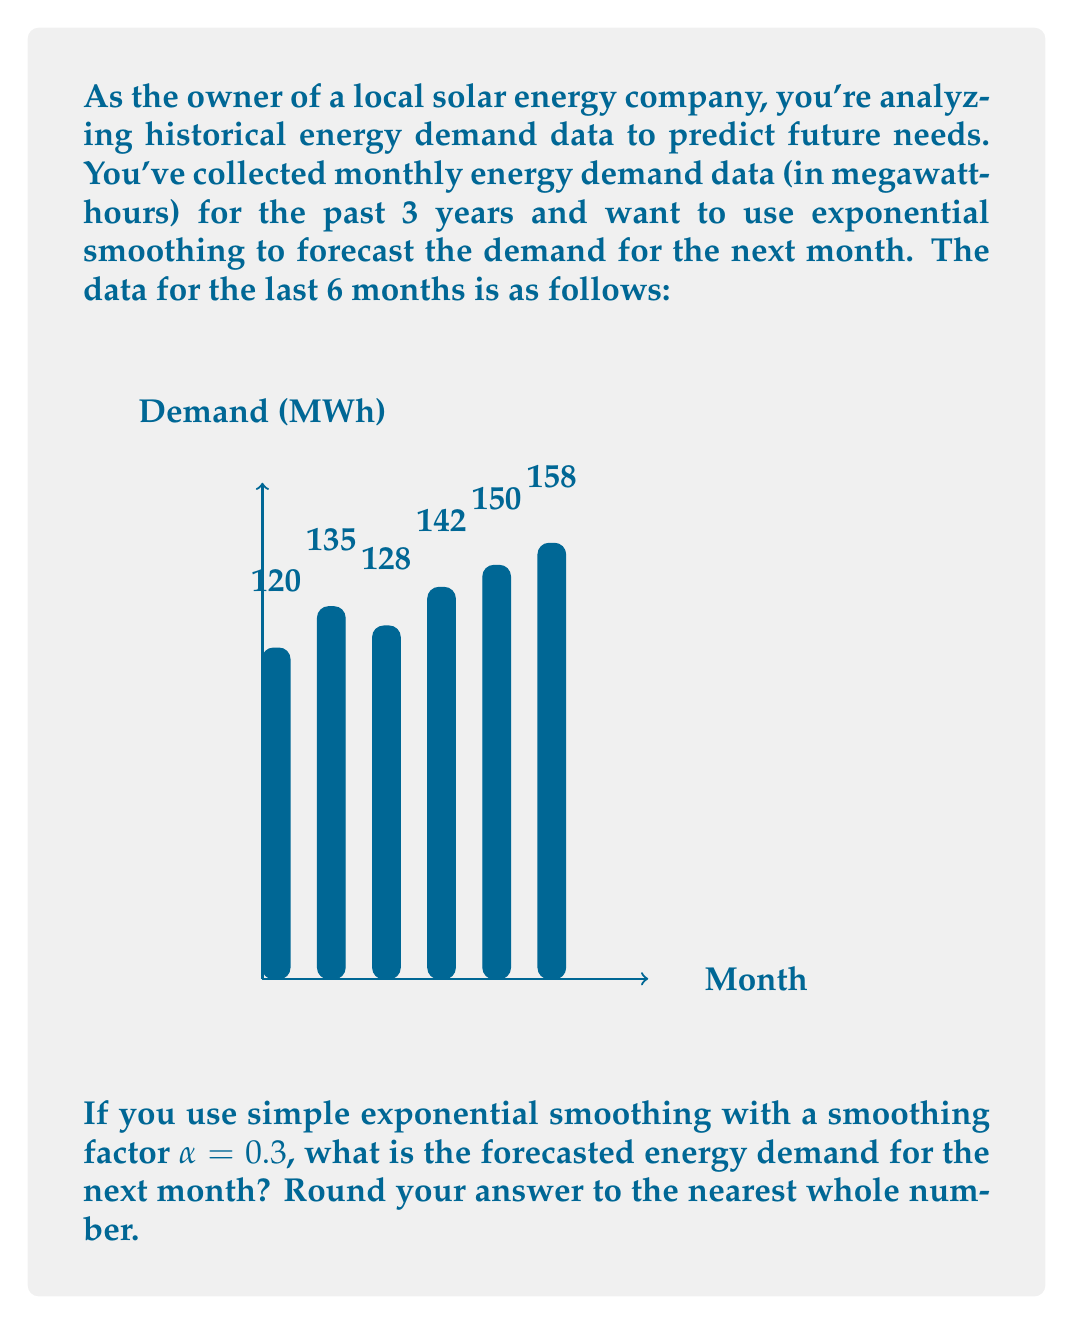Show me your answer to this math problem. To solve this problem, we'll use the simple exponential smoothing formula:

$$F_{t+1} = \alpha Y_t + (1-\alpha)F_t$$

Where:
$F_{t+1}$ is the forecast for the next period
$\alpha$ is the smoothing factor (0.3 in this case)
$Y_t$ is the actual value at time t
$F_t$ is the forecast for the current period

Let's calculate step by step:

1) We start with the most recent actual value: $Y_t = 158$ MWh

2) For $F_t$, we need to calculate the forecast for the current period. We can do this by taking the average of the previous 5 values:

   $F_t = (120 + 135 + 128 + 142 + 150) / 5 = 135$ MWh

3) Now we can plug these values into our formula:

   $F_{t+1} = 0.3(158) + (1-0.3)(135)$

4) Let's calculate:
   
   $F_{t+1} = 47.4 + 0.7(135) = 47.4 + 94.5 = 141.9$ MWh

5) Rounding to the nearest whole number:

   $F_{t+1} \approx 142$ MWh

Therefore, the forecasted energy demand for the next month is 142 MWh.
Answer: 142 MWh 